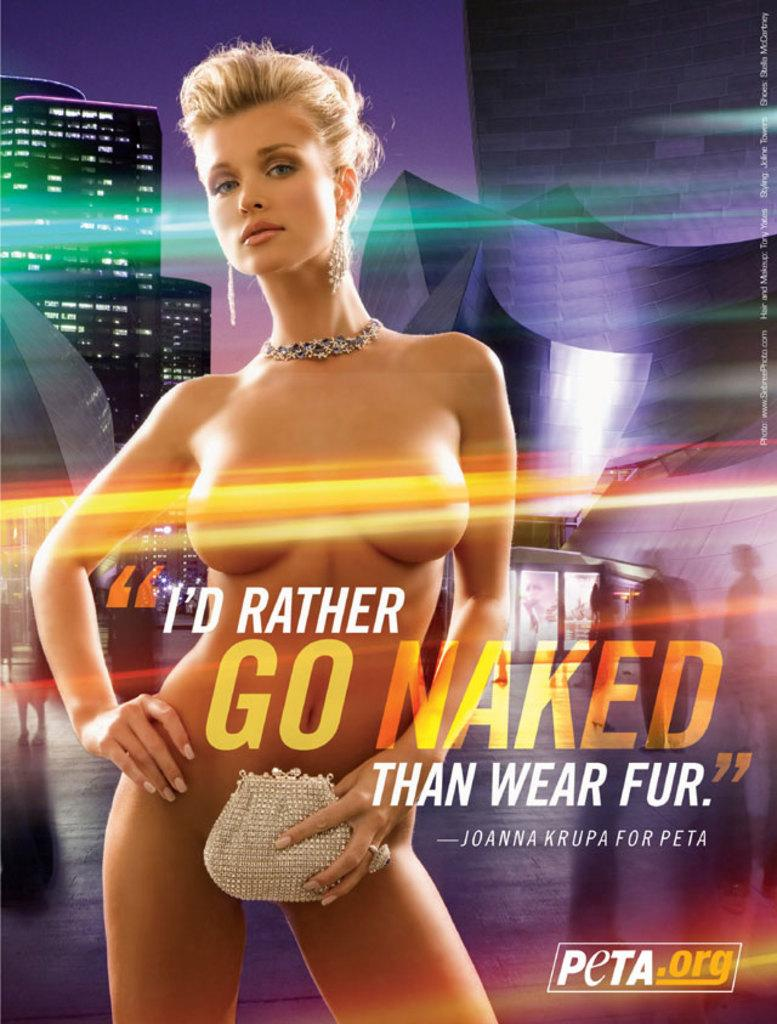Who is the main subject in the image? There is a woman in the center of the image. What can be seen in the background of the image? There is a building and the sky visible in the background of the image. What color is the balloon held by the woman in the image? There is no balloon present in the image. What type of stem is attached to the woman's clothing in the image? There is no stem attached to the woman's clothing in the image. 